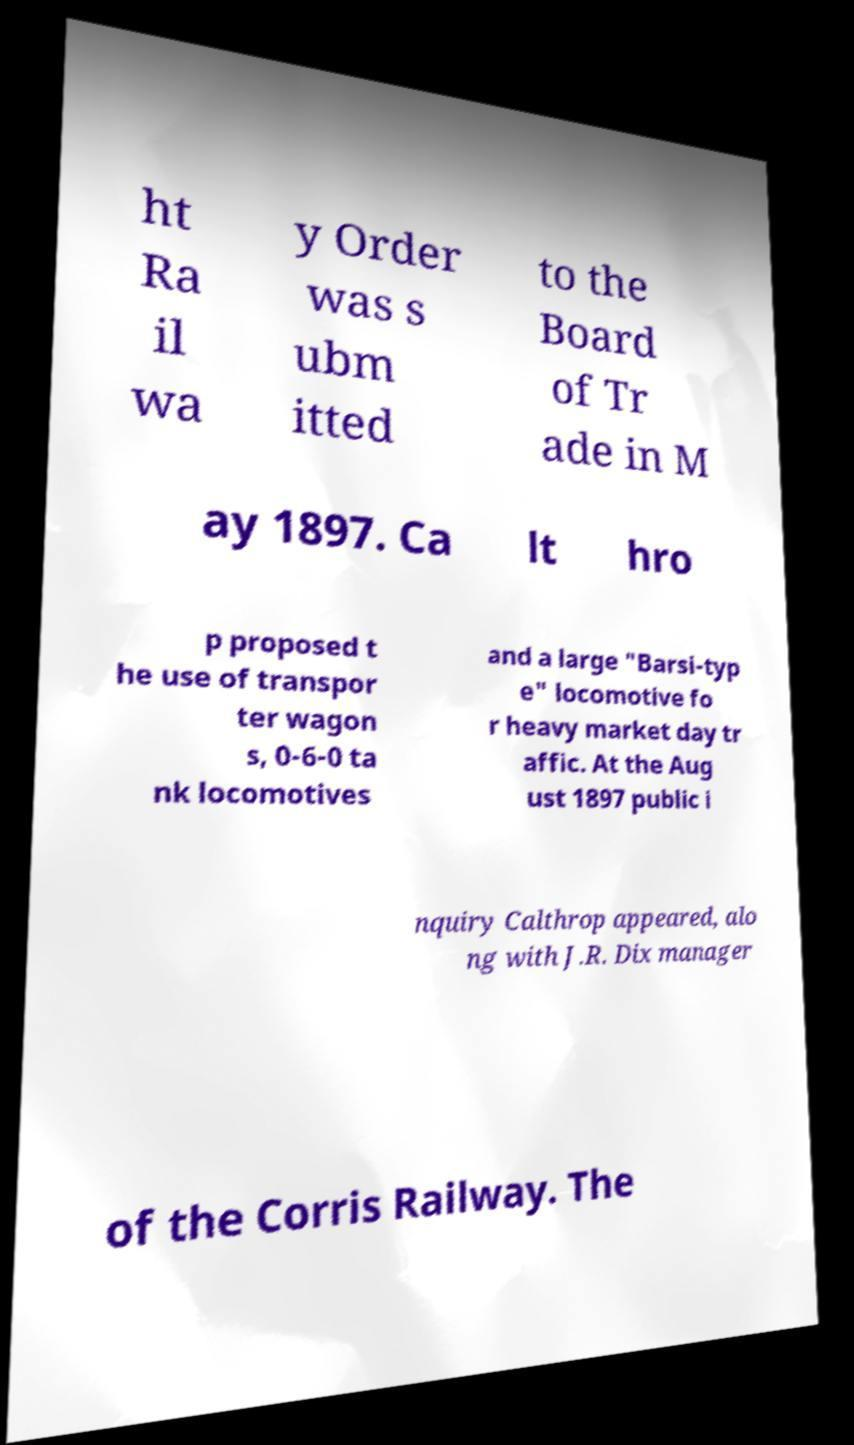I need the written content from this picture converted into text. Can you do that? ht Ra il wa y Order was s ubm itted to the Board of Tr ade in M ay 1897. Ca lt hro p proposed t he use of transpor ter wagon s, 0-6-0 ta nk locomotives and a large "Barsi-typ e" locomotive fo r heavy market day tr affic. At the Aug ust 1897 public i nquiry Calthrop appeared, alo ng with J.R. Dix manager of the Corris Railway. The 